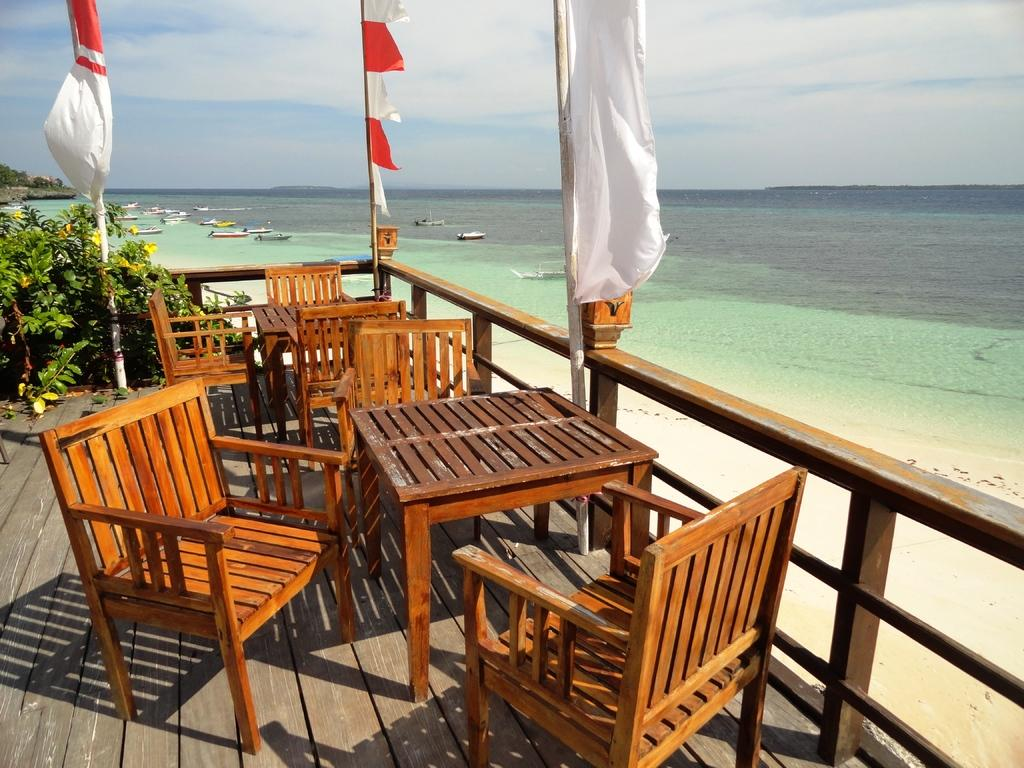What type of furniture can be seen in the image? There are tables and chairs in the image. What is the flooring material in the image? The flooring material in the image is wooden. What type of vegetation is present in the image? There are plants in the image. What is the flag associated with in the image? The flag is associated with a specific location or organization. What is visible on the ground in the image? There is water visible on the ground in the image. What type of vehicles are present in the image? There are boats in the image. What is the terrain feature in the image? There is a hill in the image. What is visible in the sky in the image? The sky is visible in the image, with clouds present. What type of pets can be seen playing with the boats in the image? There are no pets visible in the image; it features tables, chairs, a wooden floor, plants, a flag, ground, water, boats, a hill, and the sky with clouds. What is your opinion on the arrangement of the tables and chairs in the image? As an assistant, I do not have personal opinions. The conversation is based on the facts provided about the image. 